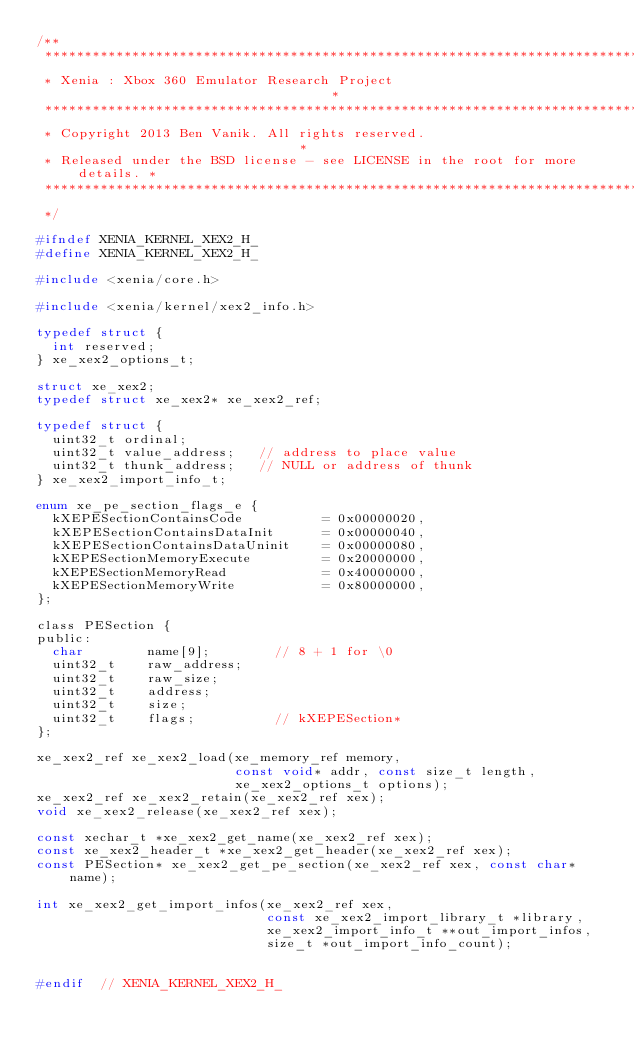Convert code to text. <code><loc_0><loc_0><loc_500><loc_500><_C_>/**
 ******************************************************************************
 * Xenia : Xbox 360 Emulator Research Project                                 *
 ******************************************************************************
 * Copyright 2013 Ben Vanik. All rights reserved.                             *
 * Released under the BSD license - see LICENSE in the root for more details. *
 ******************************************************************************
 */

#ifndef XENIA_KERNEL_XEX2_H_
#define XENIA_KERNEL_XEX2_H_

#include <xenia/core.h>

#include <xenia/kernel/xex2_info.h>

typedef struct {
  int reserved;
} xe_xex2_options_t;

struct xe_xex2;
typedef struct xe_xex2* xe_xex2_ref;

typedef struct {
  uint32_t ordinal;
  uint32_t value_address;   // address to place value
  uint32_t thunk_address;   // NULL or address of thunk
} xe_xex2_import_info_t;

enum xe_pe_section_flags_e {
  kXEPESectionContainsCode          = 0x00000020,
  kXEPESectionContainsDataInit      = 0x00000040,
  kXEPESectionContainsDataUninit    = 0x00000080,
  kXEPESectionMemoryExecute         = 0x20000000,
  kXEPESectionMemoryRead            = 0x40000000,
  kXEPESectionMemoryWrite           = 0x80000000,
};

class PESection {
public:
  char        name[9];        // 8 + 1 for \0
  uint32_t    raw_address;
  uint32_t    raw_size;
  uint32_t    address;
  uint32_t    size;
  uint32_t    flags;          // kXEPESection*
};

xe_xex2_ref xe_xex2_load(xe_memory_ref memory,
                         const void* addr, const size_t length,
                         xe_xex2_options_t options);
xe_xex2_ref xe_xex2_retain(xe_xex2_ref xex);
void xe_xex2_release(xe_xex2_ref xex);

const xechar_t *xe_xex2_get_name(xe_xex2_ref xex);
const xe_xex2_header_t *xe_xex2_get_header(xe_xex2_ref xex);
const PESection* xe_xex2_get_pe_section(xe_xex2_ref xex, const char* name);

int xe_xex2_get_import_infos(xe_xex2_ref xex,
                             const xe_xex2_import_library_t *library,
                             xe_xex2_import_info_t **out_import_infos,
                             size_t *out_import_info_count);


#endif  // XENIA_KERNEL_XEX2_H_
</code> 